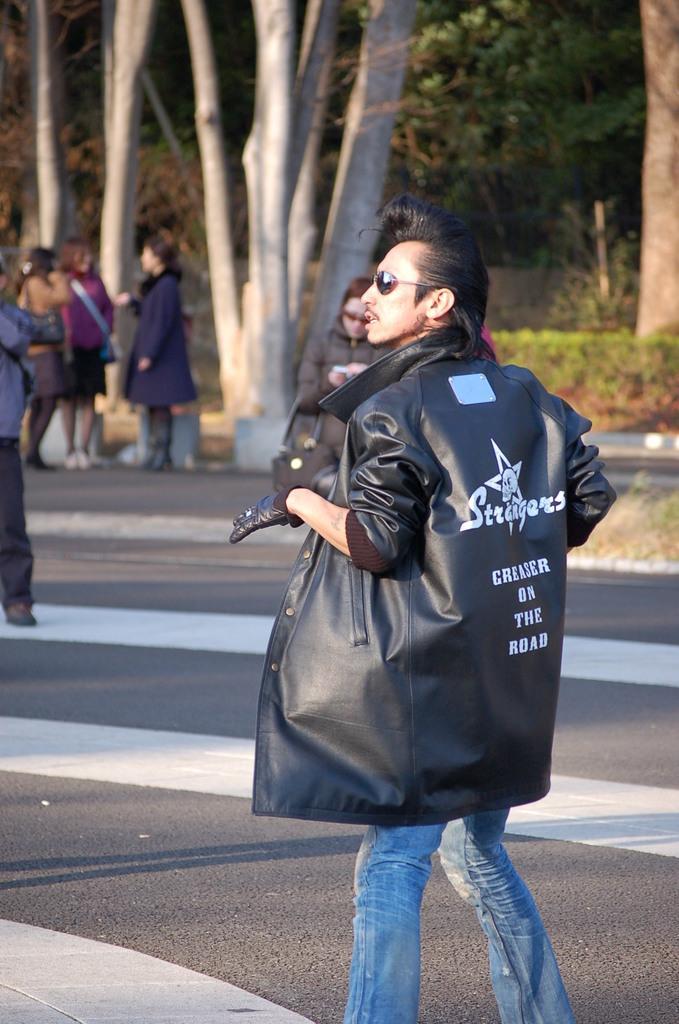How would you summarize this image in a sentence or two? In this picture I can see few people are standing and I can see trees and plants in the back. 